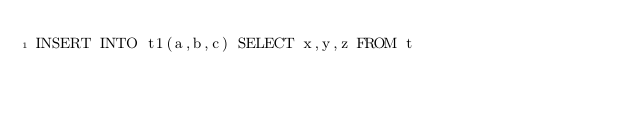<code> <loc_0><loc_0><loc_500><loc_500><_SQL_>INSERT INTO t1(a,b,c) SELECT x,y,z FROM t</code> 